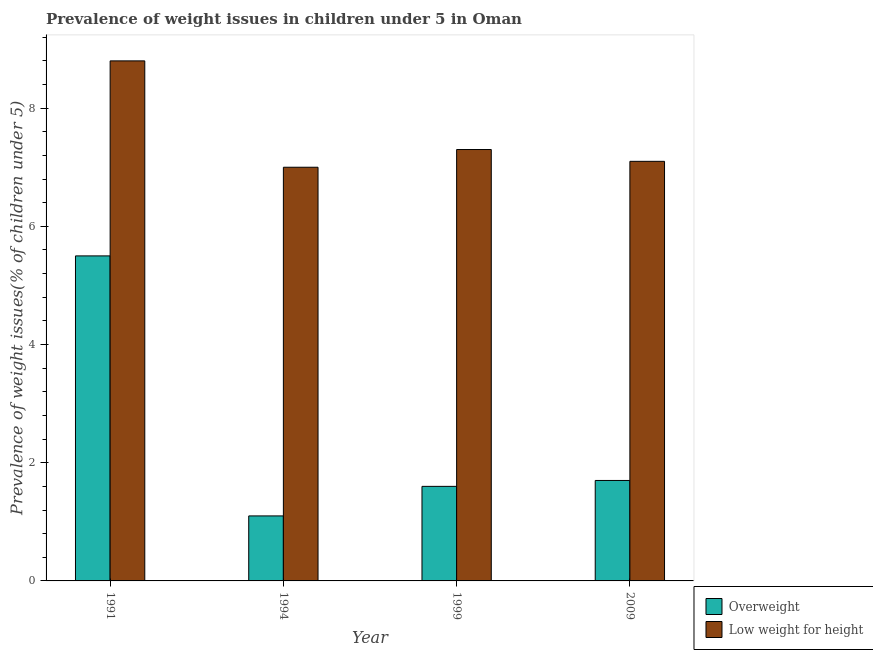How many different coloured bars are there?
Offer a terse response. 2. How many groups of bars are there?
Offer a terse response. 4. Are the number of bars on each tick of the X-axis equal?
Your answer should be compact. Yes. How many bars are there on the 2nd tick from the left?
Give a very brief answer. 2. What is the label of the 3rd group of bars from the left?
Your response must be concise. 1999. In how many cases, is the number of bars for a given year not equal to the number of legend labels?
Keep it short and to the point. 0. What is the percentage of overweight children in 1994?
Offer a very short reply. 1.1. Across all years, what is the maximum percentage of underweight children?
Keep it short and to the point. 8.8. Across all years, what is the minimum percentage of underweight children?
Provide a short and direct response. 7. In which year was the percentage of overweight children maximum?
Keep it short and to the point. 1991. What is the total percentage of overweight children in the graph?
Offer a terse response. 9.9. What is the difference between the percentage of overweight children in 1999 and that in 2009?
Ensure brevity in your answer.  -0.1. What is the difference between the percentage of underweight children in 2009 and the percentage of overweight children in 1999?
Keep it short and to the point. -0.2. What is the average percentage of underweight children per year?
Offer a very short reply. 7.55. In the year 1999, what is the difference between the percentage of overweight children and percentage of underweight children?
Your answer should be very brief. 0. In how many years, is the percentage of underweight children greater than 3.6 %?
Make the answer very short. 4. What is the ratio of the percentage of overweight children in 1994 to that in 2009?
Provide a short and direct response. 0.65. Is the percentage of overweight children in 1994 less than that in 1999?
Provide a short and direct response. Yes. Is the difference between the percentage of underweight children in 1991 and 1994 greater than the difference between the percentage of overweight children in 1991 and 1994?
Provide a succinct answer. No. What is the difference between the highest and the second highest percentage of underweight children?
Make the answer very short. 1.5. What is the difference between the highest and the lowest percentage of underweight children?
Offer a very short reply. 1.8. Is the sum of the percentage of underweight children in 1994 and 2009 greater than the maximum percentage of overweight children across all years?
Your response must be concise. Yes. What does the 2nd bar from the left in 1994 represents?
Offer a very short reply. Low weight for height. What does the 1st bar from the right in 1999 represents?
Make the answer very short. Low weight for height. What is the difference between two consecutive major ticks on the Y-axis?
Offer a very short reply. 2. Does the graph contain grids?
Ensure brevity in your answer.  No. How are the legend labels stacked?
Your answer should be compact. Vertical. What is the title of the graph?
Your response must be concise. Prevalence of weight issues in children under 5 in Oman. Does "Long-term debt" appear as one of the legend labels in the graph?
Keep it short and to the point. No. What is the label or title of the Y-axis?
Your answer should be very brief. Prevalence of weight issues(% of children under 5). What is the Prevalence of weight issues(% of children under 5) in Low weight for height in 1991?
Make the answer very short. 8.8. What is the Prevalence of weight issues(% of children under 5) in Overweight in 1994?
Your answer should be very brief. 1.1. What is the Prevalence of weight issues(% of children under 5) in Overweight in 1999?
Offer a very short reply. 1.6. What is the Prevalence of weight issues(% of children under 5) of Low weight for height in 1999?
Provide a succinct answer. 7.3. What is the Prevalence of weight issues(% of children under 5) in Overweight in 2009?
Provide a succinct answer. 1.7. What is the Prevalence of weight issues(% of children under 5) in Low weight for height in 2009?
Provide a short and direct response. 7.1. Across all years, what is the maximum Prevalence of weight issues(% of children under 5) of Low weight for height?
Your answer should be very brief. 8.8. Across all years, what is the minimum Prevalence of weight issues(% of children under 5) in Overweight?
Give a very brief answer. 1.1. Across all years, what is the minimum Prevalence of weight issues(% of children under 5) in Low weight for height?
Your response must be concise. 7. What is the total Prevalence of weight issues(% of children under 5) of Overweight in the graph?
Your answer should be compact. 9.9. What is the total Prevalence of weight issues(% of children under 5) of Low weight for height in the graph?
Make the answer very short. 30.2. What is the difference between the Prevalence of weight issues(% of children under 5) of Overweight in 1991 and that in 1999?
Offer a very short reply. 3.9. What is the difference between the Prevalence of weight issues(% of children under 5) in Overweight in 1991 and that in 2009?
Ensure brevity in your answer.  3.8. What is the difference between the Prevalence of weight issues(% of children under 5) in Low weight for height in 1994 and that in 1999?
Your answer should be compact. -0.3. What is the difference between the Prevalence of weight issues(% of children under 5) of Overweight in 1994 and that in 2009?
Give a very brief answer. -0.6. What is the difference between the Prevalence of weight issues(% of children under 5) in Low weight for height in 1994 and that in 2009?
Provide a short and direct response. -0.1. What is the difference between the Prevalence of weight issues(% of children under 5) of Low weight for height in 1999 and that in 2009?
Provide a succinct answer. 0.2. What is the difference between the Prevalence of weight issues(% of children under 5) in Overweight in 1991 and the Prevalence of weight issues(% of children under 5) in Low weight for height in 1994?
Make the answer very short. -1.5. What is the difference between the Prevalence of weight issues(% of children under 5) of Overweight in 1991 and the Prevalence of weight issues(% of children under 5) of Low weight for height in 1999?
Your response must be concise. -1.8. What is the difference between the Prevalence of weight issues(% of children under 5) of Overweight in 1991 and the Prevalence of weight issues(% of children under 5) of Low weight for height in 2009?
Your response must be concise. -1.6. What is the difference between the Prevalence of weight issues(% of children under 5) in Overweight in 1994 and the Prevalence of weight issues(% of children under 5) in Low weight for height in 2009?
Offer a very short reply. -6. What is the average Prevalence of weight issues(% of children under 5) in Overweight per year?
Ensure brevity in your answer.  2.48. What is the average Prevalence of weight issues(% of children under 5) in Low weight for height per year?
Keep it short and to the point. 7.55. In the year 1991, what is the difference between the Prevalence of weight issues(% of children under 5) of Overweight and Prevalence of weight issues(% of children under 5) of Low weight for height?
Give a very brief answer. -3.3. In the year 1994, what is the difference between the Prevalence of weight issues(% of children under 5) in Overweight and Prevalence of weight issues(% of children under 5) in Low weight for height?
Your response must be concise. -5.9. In the year 1999, what is the difference between the Prevalence of weight issues(% of children under 5) in Overweight and Prevalence of weight issues(% of children under 5) in Low weight for height?
Offer a very short reply. -5.7. In the year 2009, what is the difference between the Prevalence of weight issues(% of children under 5) in Overweight and Prevalence of weight issues(% of children under 5) in Low weight for height?
Your response must be concise. -5.4. What is the ratio of the Prevalence of weight issues(% of children under 5) of Low weight for height in 1991 to that in 1994?
Keep it short and to the point. 1.26. What is the ratio of the Prevalence of weight issues(% of children under 5) of Overweight in 1991 to that in 1999?
Offer a very short reply. 3.44. What is the ratio of the Prevalence of weight issues(% of children under 5) of Low weight for height in 1991 to that in 1999?
Provide a short and direct response. 1.21. What is the ratio of the Prevalence of weight issues(% of children under 5) in Overweight in 1991 to that in 2009?
Your answer should be very brief. 3.24. What is the ratio of the Prevalence of weight issues(% of children under 5) in Low weight for height in 1991 to that in 2009?
Your answer should be very brief. 1.24. What is the ratio of the Prevalence of weight issues(% of children under 5) in Overweight in 1994 to that in 1999?
Make the answer very short. 0.69. What is the ratio of the Prevalence of weight issues(% of children under 5) in Low weight for height in 1994 to that in 1999?
Make the answer very short. 0.96. What is the ratio of the Prevalence of weight issues(% of children under 5) of Overweight in 1994 to that in 2009?
Your answer should be very brief. 0.65. What is the ratio of the Prevalence of weight issues(% of children under 5) in Low weight for height in 1994 to that in 2009?
Make the answer very short. 0.99. What is the ratio of the Prevalence of weight issues(% of children under 5) in Overweight in 1999 to that in 2009?
Ensure brevity in your answer.  0.94. What is the ratio of the Prevalence of weight issues(% of children under 5) in Low weight for height in 1999 to that in 2009?
Your answer should be very brief. 1.03. What is the difference between the highest and the second highest Prevalence of weight issues(% of children under 5) in Low weight for height?
Provide a short and direct response. 1.5. What is the difference between the highest and the lowest Prevalence of weight issues(% of children under 5) of Low weight for height?
Make the answer very short. 1.8. 